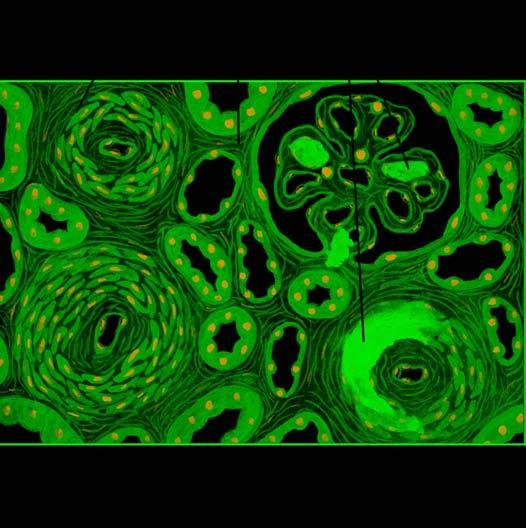re the parenchymal changes tubular loss, fine interstitial fibrosis and foci of infarction necrosis?
Answer the question using a single word or phrase. Yes 